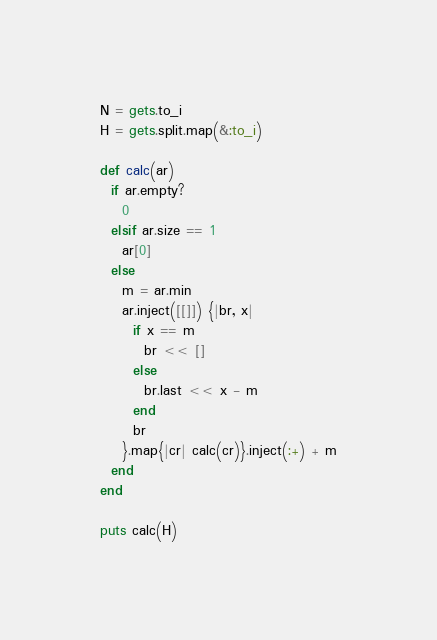Convert code to text. <code><loc_0><loc_0><loc_500><loc_500><_Ruby_>N = gets.to_i
H = gets.split.map(&:to_i)

def calc(ar)
  if ar.empty?
    0
  elsif ar.size == 1
    ar[0]
  else  
    m = ar.min
    ar.inject([[]]) {|br, x|
      if x == m
        br << []
      else  
        br.last << x - m 
      end
      br
    }.map{|cr| calc(cr)}.inject(:+) + m
  end
end 

puts calc(H)</code> 